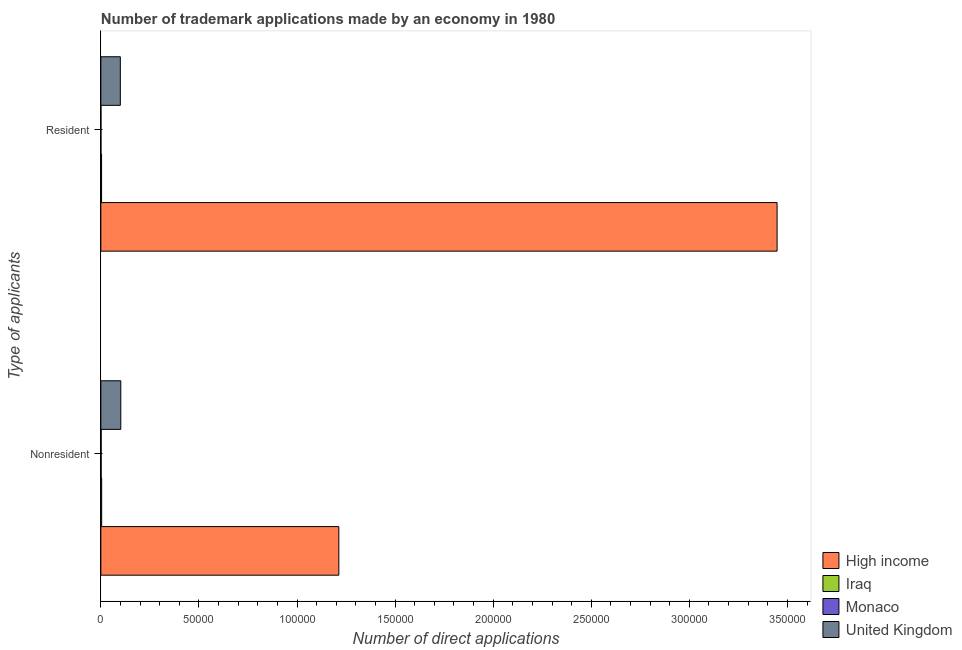Are the number of bars per tick equal to the number of legend labels?
Provide a short and direct response. Yes. Are the number of bars on each tick of the Y-axis equal?
Offer a very short reply. Yes. How many bars are there on the 2nd tick from the bottom?
Make the answer very short. 4. What is the label of the 1st group of bars from the top?
Offer a terse response. Resident. What is the number of trademark applications made by non residents in Monaco?
Your response must be concise. 157. Across all countries, what is the maximum number of trademark applications made by residents?
Ensure brevity in your answer.  3.45e+05. Across all countries, what is the minimum number of trademark applications made by non residents?
Keep it short and to the point. 157. In which country was the number of trademark applications made by non residents maximum?
Keep it short and to the point. High income. In which country was the number of trademark applications made by residents minimum?
Provide a short and direct response. Monaco. What is the total number of trademark applications made by residents in the graph?
Keep it short and to the point. 3.55e+05. What is the difference between the number of trademark applications made by residents in United Kingdom and that in Monaco?
Your answer should be compact. 9882. What is the difference between the number of trademark applications made by non residents in Iraq and the number of trademark applications made by residents in High income?
Your answer should be compact. -3.44e+05. What is the average number of trademark applications made by non residents per country?
Give a very brief answer. 3.30e+04. What is the difference between the number of trademark applications made by non residents and number of trademark applications made by residents in Iraq?
Your response must be concise. 56. What is the ratio of the number of trademark applications made by non residents in High income to that in United Kingdom?
Provide a succinct answer. 11.93. Is the number of trademark applications made by residents in Iraq less than that in Monaco?
Ensure brevity in your answer.  No. In how many countries, is the number of trademark applications made by residents greater than the average number of trademark applications made by residents taken over all countries?
Keep it short and to the point. 1. What does the 1st bar from the bottom in Nonresident represents?
Ensure brevity in your answer.  High income. How many bars are there?
Provide a short and direct response. 8. Are all the bars in the graph horizontal?
Your answer should be very brief. Yes. How many countries are there in the graph?
Make the answer very short. 4. Does the graph contain any zero values?
Make the answer very short. No. Where does the legend appear in the graph?
Offer a very short reply. Bottom right. How are the legend labels stacked?
Provide a succinct answer. Vertical. What is the title of the graph?
Your answer should be compact. Number of trademark applications made by an economy in 1980. What is the label or title of the X-axis?
Ensure brevity in your answer.  Number of direct applications. What is the label or title of the Y-axis?
Your response must be concise. Type of applicants. What is the Number of direct applications in High income in Nonresident?
Offer a very short reply. 1.21e+05. What is the Number of direct applications in Iraq in Nonresident?
Ensure brevity in your answer.  424. What is the Number of direct applications of Monaco in Nonresident?
Your response must be concise. 157. What is the Number of direct applications of United Kingdom in Nonresident?
Keep it short and to the point. 1.02e+04. What is the Number of direct applications in High income in Resident?
Give a very brief answer. 3.45e+05. What is the Number of direct applications of Iraq in Resident?
Your response must be concise. 368. What is the Number of direct applications in United Kingdom in Resident?
Your answer should be very brief. 9933. Across all Type of applicants, what is the maximum Number of direct applications of High income?
Your answer should be very brief. 3.45e+05. Across all Type of applicants, what is the maximum Number of direct applications of Iraq?
Give a very brief answer. 424. Across all Type of applicants, what is the maximum Number of direct applications in Monaco?
Offer a terse response. 157. Across all Type of applicants, what is the maximum Number of direct applications of United Kingdom?
Give a very brief answer. 1.02e+04. Across all Type of applicants, what is the minimum Number of direct applications of High income?
Keep it short and to the point. 1.21e+05. Across all Type of applicants, what is the minimum Number of direct applications in Iraq?
Offer a terse response. 368. Across all Type of applicants, what is the minimum Number of direct applications in Monaco?
Offer a terse response. 51. Across all Type of applicants, what is the minimum Number of direct applications in United Kingdom?
Offer a very short reply. 9933. What is the total Number of direct applications in High income in the graph?
Give a very brief answer. 4.66e+05. What is the total Number of direct applications of Iraq in the graph?
Offer a very short reply. 792. What is the total Number of direct applications in Monaco in the graph?
Offer a very short reply. 208. What is the total Number of direct applications in United Kingdom in the graph?
Make the answer very short. 2.01e+04. What is the difference between the Number of direct applications in High income in Nonresident and that in Resident?
Offer a terse response. -2.23e+05. What is the difference between the Number of direct applications of Iraq in Nonresident and that in Resident?
Ensure brevity in your answer.  56. What is the difference between the Number of direct applications of Monaco in Nonresident and that in Resident?
Offer a terse response. 106. What is the difference between the Number of direct applications of United Kingdom in Nonresident and that in Resident?
Provide a short and direct response. 236. What is the difference between the Number of direct applications in High income in Nonresident and the Number of direct applications in Iraq in Resident?
Keep it short and to the point. 1.21e+05. What is the difference between the Number of direct applications in High income in Nonresident and the Number of direct applications in Monaco in Resident?
Provide a short and direct response. 1.21e+05. What is the difference between the Number of direct applications of High income in Nonresident and the Number of direct applications of United Kingdom in Resident?
Ensure brevity in your answer.  1.11e+05. What is the difference between the Number of direct applications in Iraq in Nonresident and the Number of direct applications in Monaco in Resident?
Give a very brief answer. 373. What is the difference between the Number of direct applications in Iraq in Nonresident and the Number of direct applications in United Kingdom in Resident?
Your response must be concise. -9509. What is the difference between the Number of direct applications of Monaco in Nonresident and the Number of direct applications of United Kingdom in Resident?
Keep it short and to the point. -9776. What is the average Number of direct applications in High income per Type of applicants?
Offer a very short reply. 2.33e+05. What is the average Number of direct applications in Iraq per Type of applicants?
Ensure brevity in your answer.  396. What is the average Number of direct applications in Monaco per Type of applicants?
Provide a succinct answer. 104. What is the average Number of direct applications in United Kingdom per Type of applicants?
Make the answer very short. 1.01e+04. What is the difference between the Number of direct applications in High income and Number of direct applications in Iraq in Nonresident?
Provide a succinct answer. 1.21e+05. What is the difference between the Number of direct applications of High income and Number of direct applications of Monaco in Nonresident?
Keep it short and to the point. 1.21e+05. What is the difference between the Number of direct applications in High income and Number of direct applications in United Kingdom in Nonresident?
Provide a short and direct response. 1.11e+05. What is the difference between the Number of direct applications in Iraq and Number of direct applications in Monaco in Nonresident?
Provide a succinct answer. 267. What is the difference between the Number of direct applications in Iraq and Number of direct applications in United Kingdom in Nonresident?
Your answer should be very brief. -9745. What is the difference between the Number of direct applications of Monaco and Number of direct applications of United Kingdom in Nonresident?
Offer a terse response. -1.00e+04. What is the difference between the Number of direct applications of High income and Number of direct applications of Iraq in Resident?
Provide a short and direct response. 3.44e+05. What is the difference between the Number of direct applications of High income and Number of direct applications of Monaco in Resident?
Offer a very short reply. 3.45e+05. What is the difference between the Number of direct applications of High income and Number of direct applications of United Kingdom in Resident?
Provide a short and direct response. 3.35e+05. What is the difference between the Number of direct applications in Iraq and Number of direct applications in Monaco in Resident?
Offer a very short reply. 317. What is the difference between the Number of direct applications in Iraq and Number of direct applications in United Kingdom in Resident?
Keep it short and to the point. -9565. What is the difference between the Number of direct applications in Monaco and Number of direct applications in United Kingdom in Resident?
Ensure brevity in your answer.  -9882. What is the ratio of the Number of direct applications of High income in Nonresident to that in Resident?
Offer a terse response. 0.35. What is the ratio of the Number of direct applications in Iraq in Nonresident to that in Resident?
Your response must be concise. 1.15. What is the ratio of the Number of direct applications of Monaco in Nonresident to that in Resident?
Provide a succinct answer. 3.08. What is the ratio of the Number of direct applications in United Kingdom in Nonresident to that in Resident?
Ensure brevity in your answer.  1.02. What is the difference between the highest and the second highest Number of direct applications in High income?
Offer a very short reply. 2.23e+05. What is the difference between the highest and the second highest Number of direct applications in Iraq?
Provide a short and direct response. 56. What is the difference between the highest and the second highest Number of direct applications in Monaco?
Provide a short and direct response. 106. What is the difference between the highest and the second highest Number of direct applications in United Kingdom?
Give a very brief answer. 236. What is the difference between the highest and the lowest Number of direct applications of High income?
Give a very brief answer. 2.23e+05. What is the difference between the highest and the lowest Number of direct applications of Iraq?
Offer a terse response. 56. What is the difference between the highest and the lowest Number of direct applications in Monaco?
Provide a short and direct response. 106. What is the difference between the highest and the lowest Number of direct applications in United Kingdom?
Your answer should be compact. 236. 